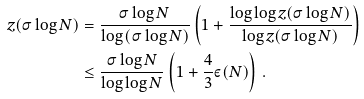Convert formula to latex. <formula><loc_0><loc_0><loc_500><loc_500>z ( \sigma \log N ) & = \frac { \sigma \log N } { \log \left ( \sigma \log N \right ) } \left ( 1 + \frac { \log \log z ( \sigma \log N ) } { \log z ( \sigma \log N ) } \right ) \\ & \leq \frac { \sigma \log N } { \log \log N } \left ( 1 + \frac { 4 } { 3 } \varepsilon ( N ) \right ) \, .</formula> 